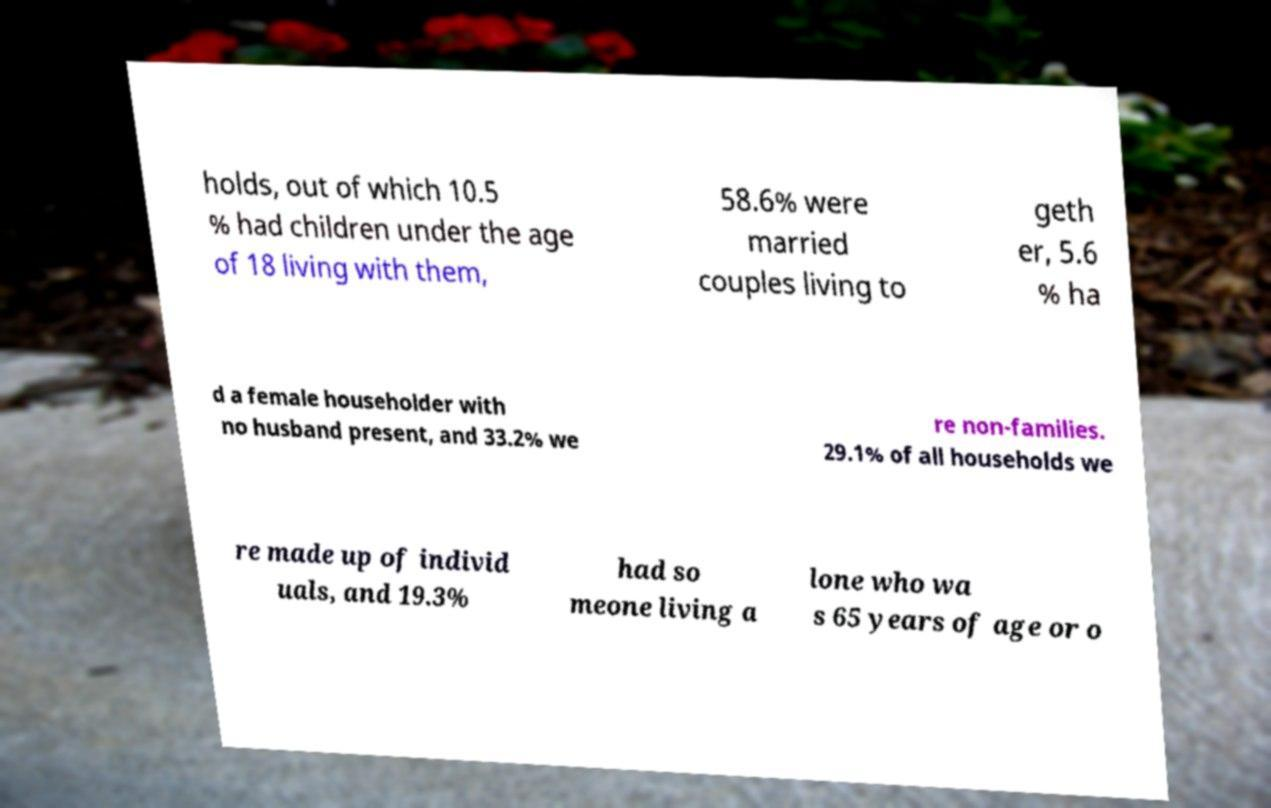Can you read and provide the text displayed in the image?This photo seems to have some interesting text. Can you extract and type it out for me? holds, out of which 10.5 % had children under the age of 18 living with them, 58.6% were married couples living to geth er, 5.6 % ha d a female householder with no husband present, and 33.2% we re non-families. 29.1% of all households we re made up of individ uals, and 19.3% had so meone living a lone who wa s 65 years of age or o 